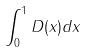Convert formula to latex. <formula><loc_0><loc_0><loc_500><loc_500>\int _ { 0 } ^ { 1 } D ( x ) d x</formula> 